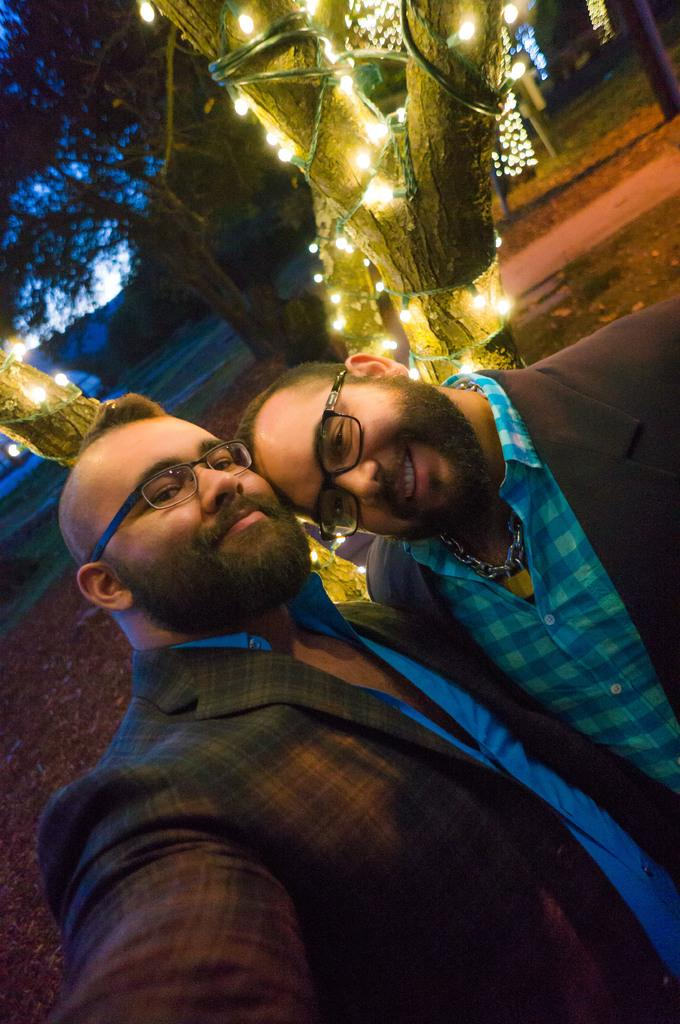How many people are in the image? There are two men in the image. What are the men wearing? The men are wearing coats. What can be seen behind the men? There are trees with lights behind the men. What type of wire can be seen connecting the trees in the image? There is no wire connecting the trees in the image; only trees with lights are present. Can you tell me how many pickles are on the ground in the image? There are no pickles present in the image. 